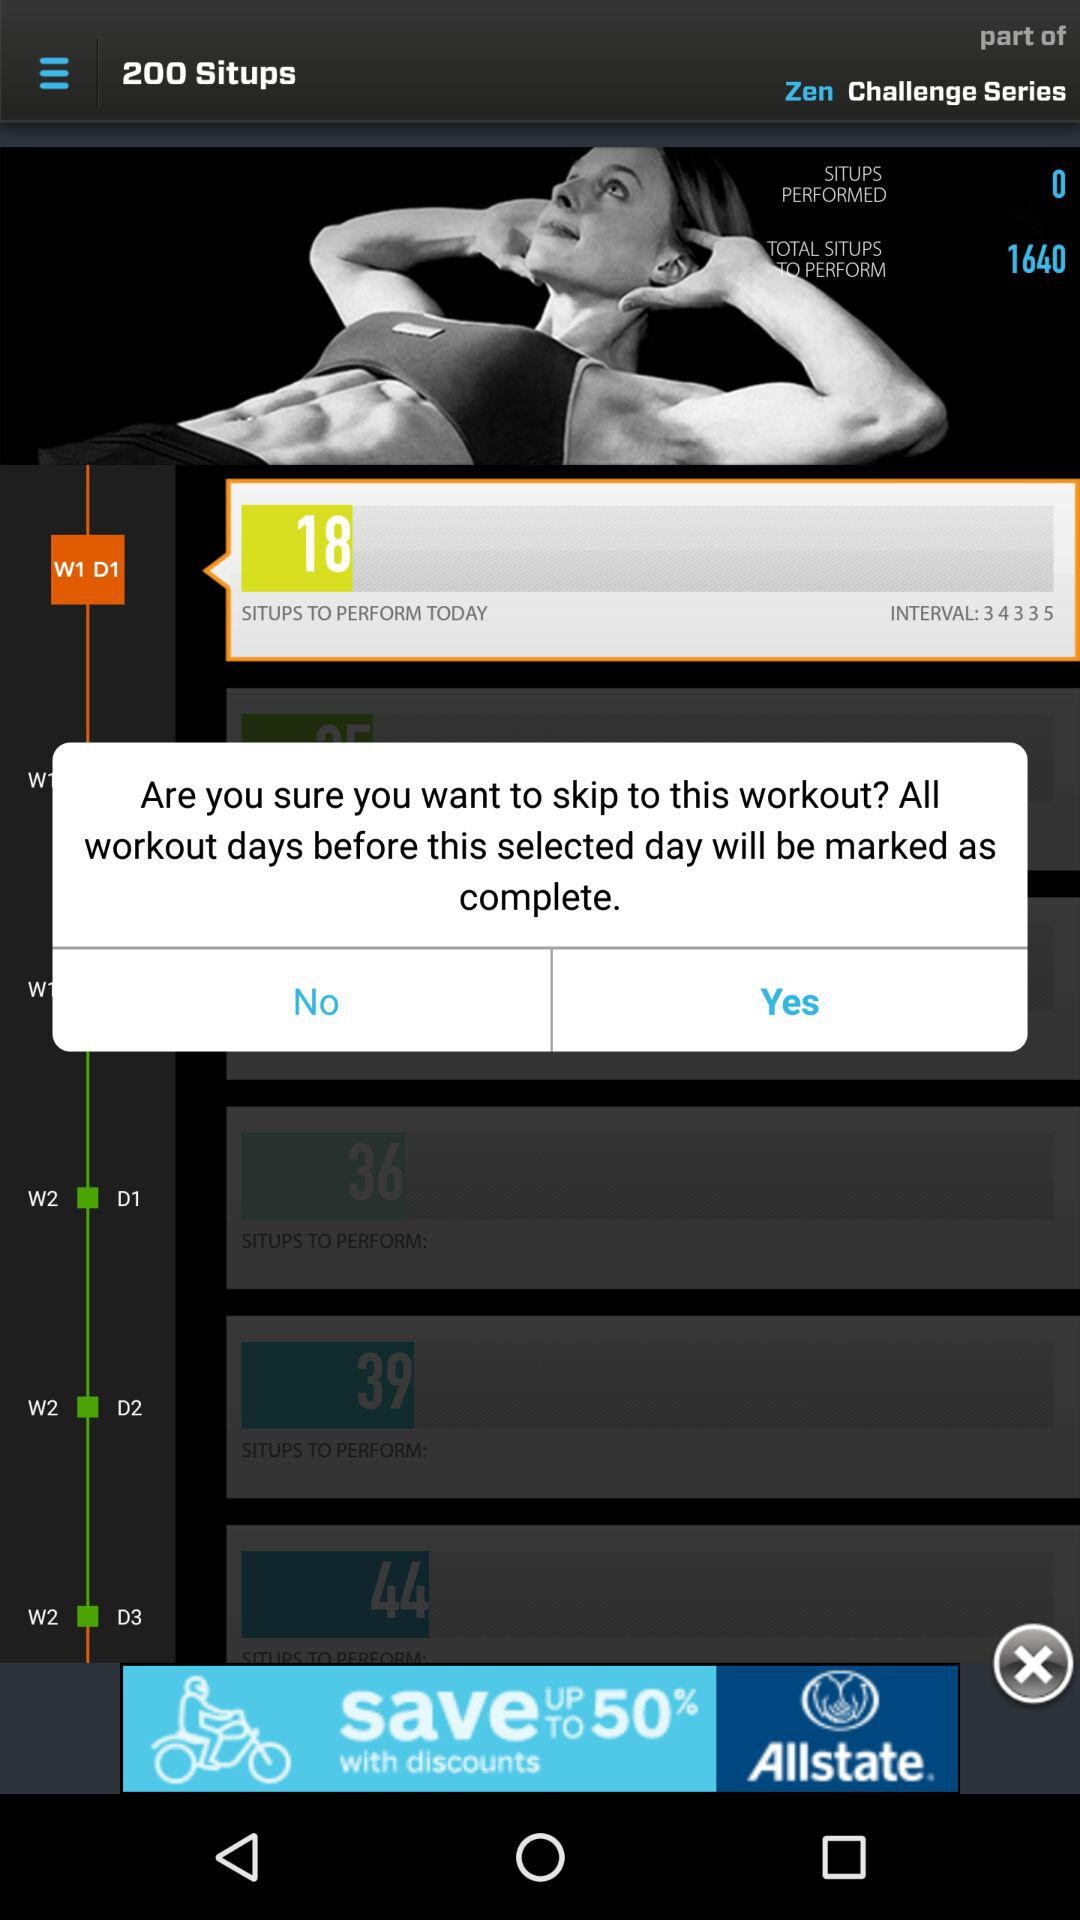What is the count of situps to be performed on W2 D2? The count of situps to be performed is 39. 